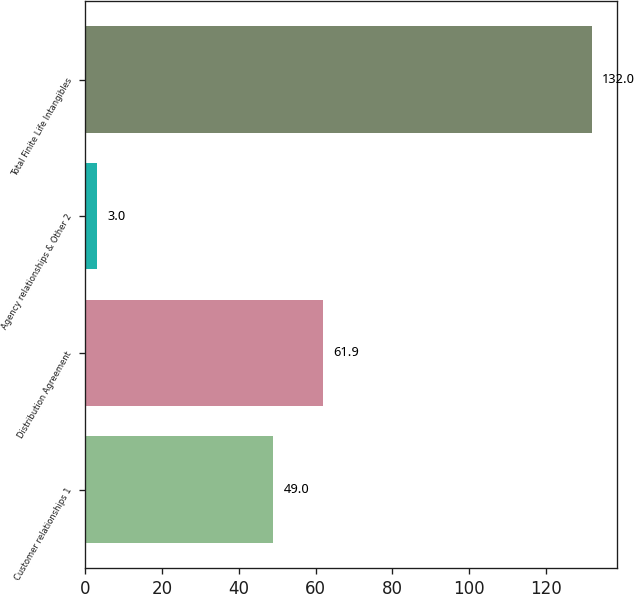Convert chart. <chart><loc_0><loc_0><loc_500><loc_500><bar_chart><fcel>Customer relationships 1<fcel>Distribution Agreement<fcel>Agency relationships & Other 2<fcel>Total Finite Life Intangibles<nl><fcel>49<fcel>61.9<fcel>3<fcel>132<nl></chart> 